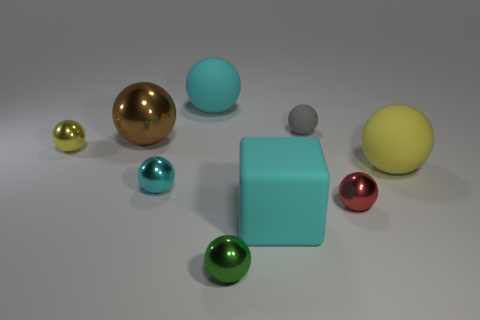Is the brown sphere the same size as the red metallic ball?
Make the answer very short. No. How many things are big rubber balls or big cyan rubber objects that are on the right side of the large cyan sphere?
Offer a very short reply. 3. There is a green thing that is the same size as the red metallic thing; what is it made of?
Ensure brevity in your answer.  Metal. What is the material of the large thing that is in front of the small gray rubber thing and to the left of the tiny green object?
Your answer should be very brief. Metal. Are there any gray spheres on the right side of the big rubber thing in front of the cyan metallic thing?
Ensure brevity in your answer.  Yes. There is a cyan object that is in front of the gray rubber ball and on the right side of the tiny cyan shiny sphere; what is its size?
Provide a succinct answer. Large. What number of brown things are blocks or big objects?
Give a very brief answer. 1. What is the shape of the cyan matte object that is the same size as the cyan matte sphere?
Give a very brief answer. Cube. How many other things are the same color as the large rubber block?
Offer a very short reply. 2. There is a cyan matte object that is right of the large rubber thing that is behind the small yellow shiny thing; what is its size?
Keep it short and to the point. Large. 